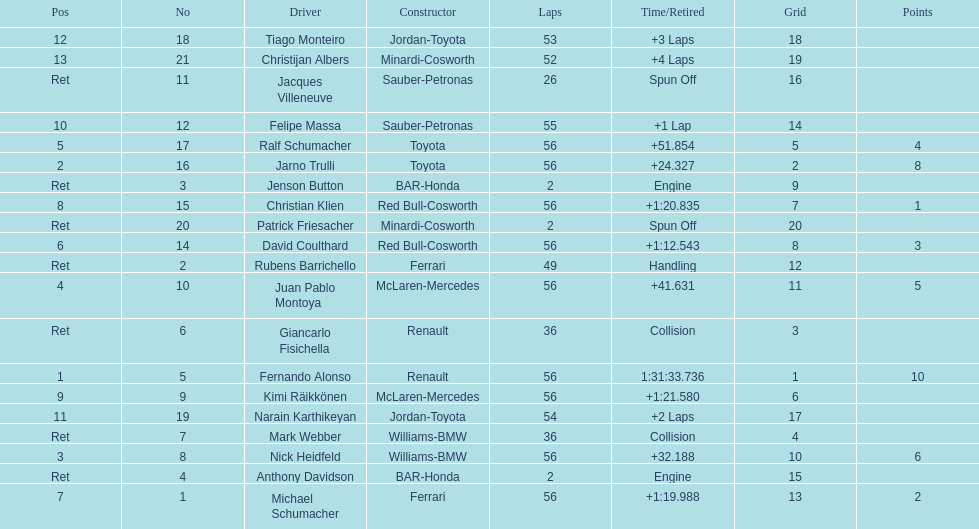How many drivers were retired before the race could end? 7. 